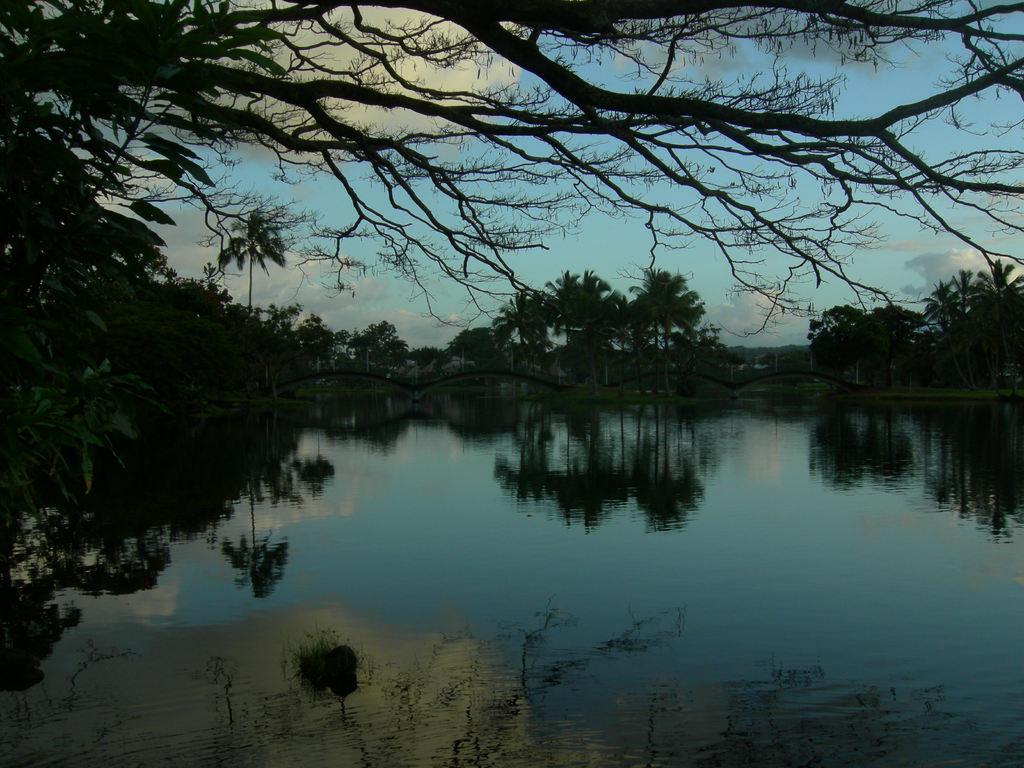Can you describe this image briefly? This picture is clicked outside. In the foreground we can see a water body and we can see the reflections of the trees and the reflections of some other objects. In the background we can see the sky, trees, bridge and some other objects and we can see the clouds. 